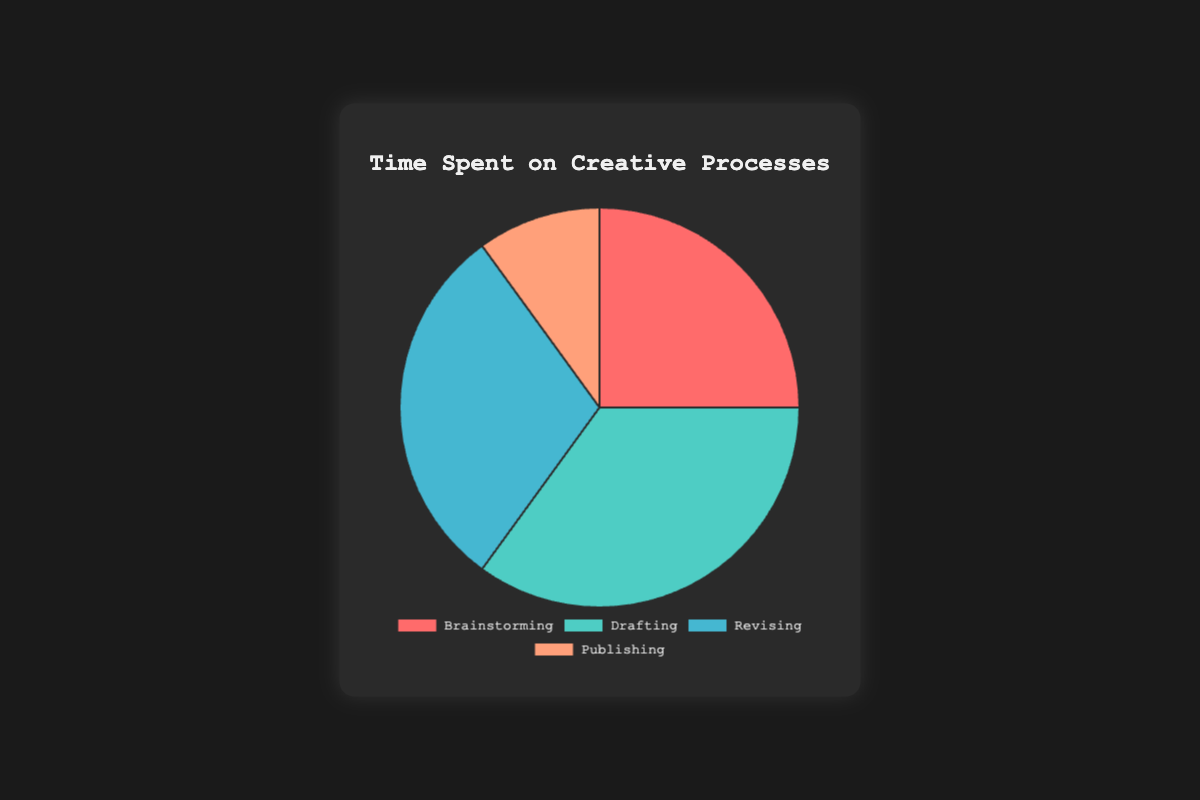What percentage of time is spent on Drafting and Revising together? Brainstorming takes 25%, Drafting 35%, Revising 30%, and Publishing 10%. Adding Drafting's 35% and Revising's 30% gives us 65%.
Answer: 65% Which creative process takes the least amount of time? The pie chart shows Brainstorming at 25%, Drafting at 35%, Revising at 30%, and Publishing at 10%. Clearly, Publishing at 10% is the smallest percentage.
Answer: Publishing By how much percentage does the Revising time exceed the Brainstorming time? The pie chart shows Brainstorming at 25% and Revising at 30%. Subtract 25% from 30% to get 5%.
Answer: 5% What fraction of the total time is spent on Revising? The pie chart shows Revising at 30%, which is equivalent to 30 out of 100 or 30/100. Simplified, this fraction is 3/10.
Answer: 3/10 What is the total percentage of time spent on Brainstorming, Drafting, and Publishing combined? Adding the percentages for Brainstorming (25%), Drafting (35%), and Publishing (10%) gives us 25% + 35% + 10% = 70%.
Answer: 70% How does the percentage of time spent on Publishing compare to the percentage of time spent on Brainstorming? Publishing takes 10%, and Brainstorming takes 25%. 10% is less than 25%.
Answer: less than Which creative process takes up the second most amount of time? The pie chart shows Drafting (35%), Brainstorming (25%), Revising (30%), and Publishing (10%). Revising with 30% is second to Drafting (35%).
Answer: Revising What percentage of the overall time is not spent on Drafting? The pie chart shows Drafting at 35%. Subtracting this from 100% gives 100% - 35% = 65%.
Answer: 65% 